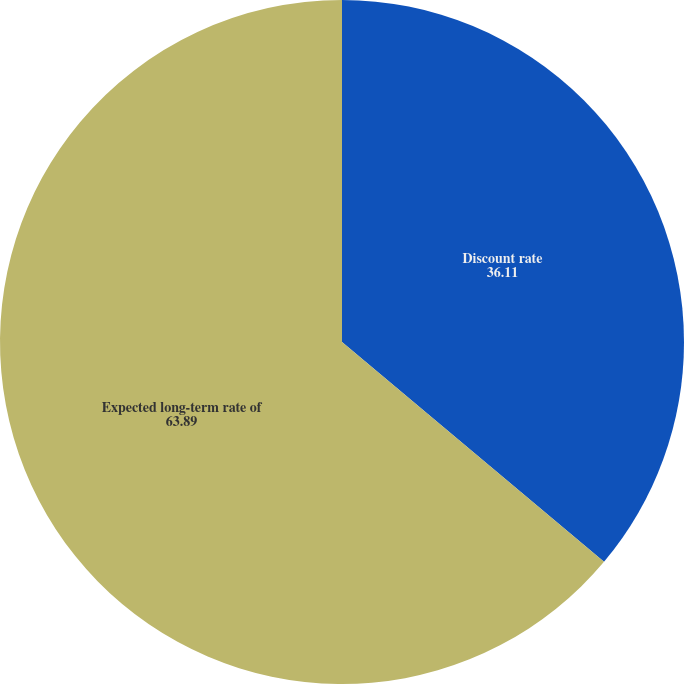Convert chart. <chart><loc_0><loc_0><loc_500><loc_500><pie_chart><fcel>Discount rate<fcel>Expected long-term rate of<nl><fcel>36.11%<fcel>63.89%<nl></chart> 